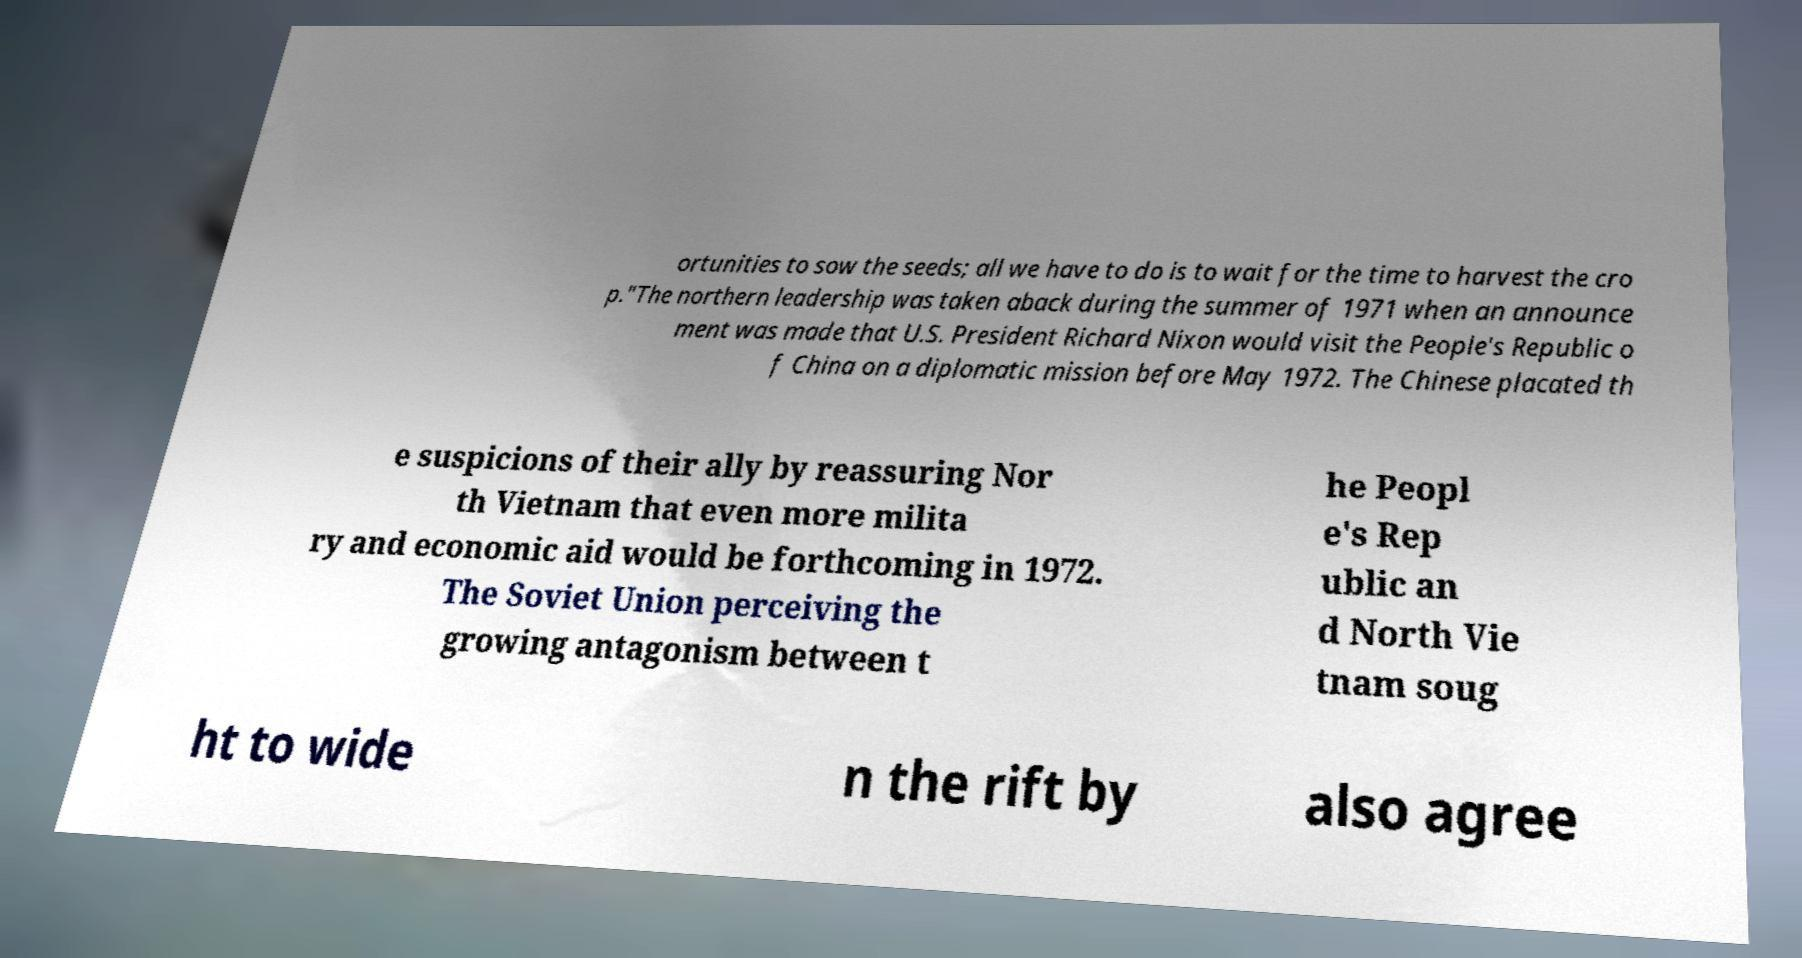Could you assist in decoding the text presented in this image and type it out clearly? ortunities to sow the seeds; all we have to do is to wait for the time to harvest the cro p."The northern leadership was taken aback during the summer of 1971 when an announce ment was made that U.S. President Richard Nixon would visit the People's Republic o f China on a diplomatic mission before May 1972. The Chinese placated th e suspicions of their ally by reassuring Nor th Vietnam that even more milita ry and economic aid would be forthcoming in 1972. The Soviet Union perceiving the growing antagonism between t he Peopl e's Rep ublic an d North Vie tnam soug ht to wide n the rift by also agree 